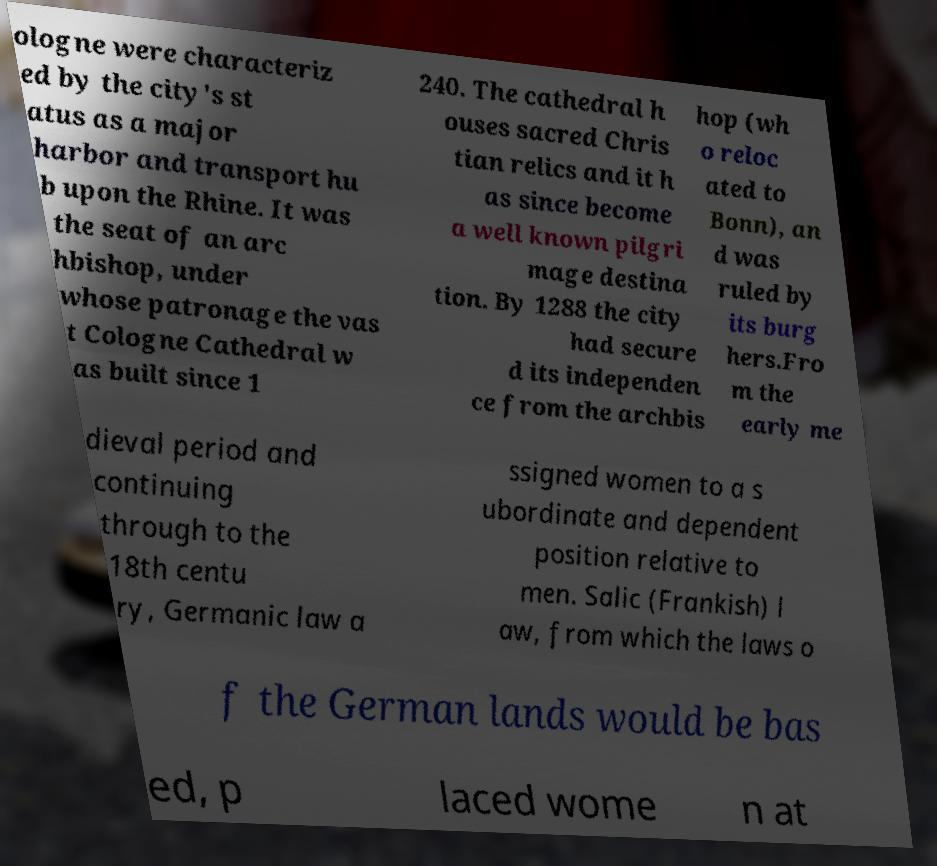I need the written content from this picture converted into text. Can you do that? ologne were characteriz ed by the city's st atus as a major harbor and transport hu b upon the Rhine. It was the seat of an arc hbishop, under whose patronage the vas t Cologne Cathedral w as built since 1 240. The cathedral h ouses sacred Chris tian relics and it h as since become a well known pilgri mage destina tion. By 1288 the city had secure d its independen ce from the archbis hop (wh o reloc ated to Bonn), an d was ruled by its burg hers.Fro m the early me dieval period and continuing through to the 18th centu ry, Germanic law a ssigned women to a s ubordinate and dependent position relative to men. Salic (Frankish) l aw, from which the laws o f the German lands would be bas ed, p laced wome n at 